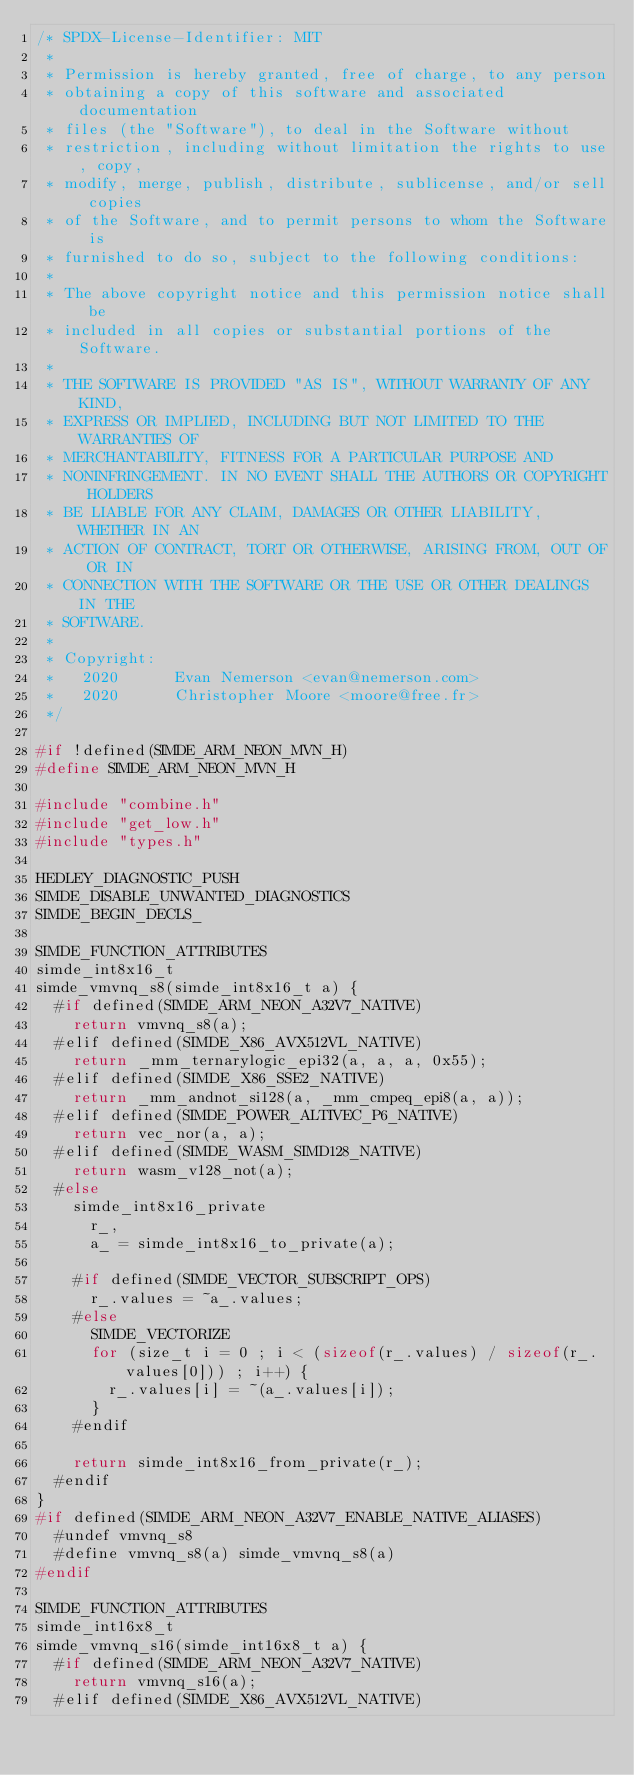<code> <loc_0><loc_0><loc_500><loc_500><_C_>/* SPDX-License-Identifier: MIT
 *
 * Permission is hereby granted, free of charge, to any person
 * obtaining a copy of this software and associated documentation
 * files (the "Software"), to deal in the Software without
 * restriction, including without limitation the rights to use, copy,
 * modify, merge, publish, distribute, sublicense, and/or sell copies
 * of the Software, and to permit persons to whom the Software is
 * furnished to do so, subject to the following conditions:
 *
 * The above copyright notice and this permission notice shall be
 * included in all copies or substantial portions of the Software.
 *
 * THE SOFTWARE IS PROVIDED "AS IS", WITHOUT WARRANTY OF ANY KIND,
 * EXPRESS OR IMPLIED, INCLUDING BUT NOT LIMITED TO THE WARRANTIES OF
 * MERCHANTABILITY, FITNESS FOR A PARTICULAR PURPOSE AND
 * NONINFRINGEMENT. IN NO EVENT SHALL THE AUTHORS OR COPYRIGHT HOLDERS
 * BE LIABLE FOR ANY CLAIM, DAMAGES OR OTHER LIABILITY, WHETHER IN AN
 * ACTION OF CONTRACT, TORT OR OTHERWISE, ARISING FROM, OUT OF OR IN
 * CONNECTION WITH THE SOFTWARE OR THE USE OR OTHER DEALINGS IN THE
 * SOFTWARE.
 *
 * Copyright:
 *   2020      Evan Nemerson <evan@nemerson.com>
 *   2020      Christopher Moore <moore@free.fr>
 */

#if !defined(SIMDE_ARM_NEON_MVN_H)
#define SIMDE_ARM_NEON_MVN_H

#include "combine.h"
#include "get_low.h"
#include "types.h"

HEDLEY_DIAGNOSTIC_PUSH
SIMDE_DISABLE_UNWANTED_DIAGNOSTICS
SIMDE_BEGIN_DECLS_

SIMDE_FUNCTION_ATTRIBUTES
simde_int8x16_t
simde_vmvnq_s8(simde_int8x16_t a) {
  #if defined(SIMDE_ARM_NEON_A32V7_NATIVE)
    return vmvnq_s8(a);
  #elif defined(SIMDE_X86_AVX512VL_NATIVE)
    return _mm_ternarylogic_epi32(a, a, a, 0x55);
  #elif defined(SIMDE_X86_SSE2_NATIVE)
    return _mm_andnot_si128(a, _mm_cmpeq_epi8(a, a));
  #elif defined(SIMDE_POWER_ALTIVEC_P6_NATIVE)
    return vec_nor(a, a);
  #elif defined(SIMDE_WASM_SIMD128_NATIVE)
    return wasm_v128_not(a);
  #else
    simde_int8x16_private
      r_,
      a_ = simde_int8x16_to_private(a);

    #if defined(SIMDE_VECTOR_SUBSCRIPT_OPS)
      r_.values = ~a_.values;
    #else
      SIMDE_VECTORIZE
      for (size_t i = 0 ; i < (sizeof(r_.values) / sizeof(r_.values[0])) ; i++) {
        r_.values[i] = ~(a_.values[i]);
      }
    #endif

    return simde_int8x16_from_private(r_);
  #endif
}
#if defined(SIMDE_ARM_NEON_A32V7_ENABLE_NATIVE_ALIASES)
  #undef vmvnq_s8
  #define vmvnq_s8(a) simde_vmvnq_s8(a)
#endif

SIMDE_FUNCTION_ATTRIBUTES
simde_int16x8_t
simde_vmvnq_s16(simde_int16x8_t a) {
  #if defined(SIMDE_ARM_NEON_A32V7_NATIVE)
    return vmvnq_s16(a);
  #elif defined(SIMDE_X86_AVX512VL_NATIVE)</code> 